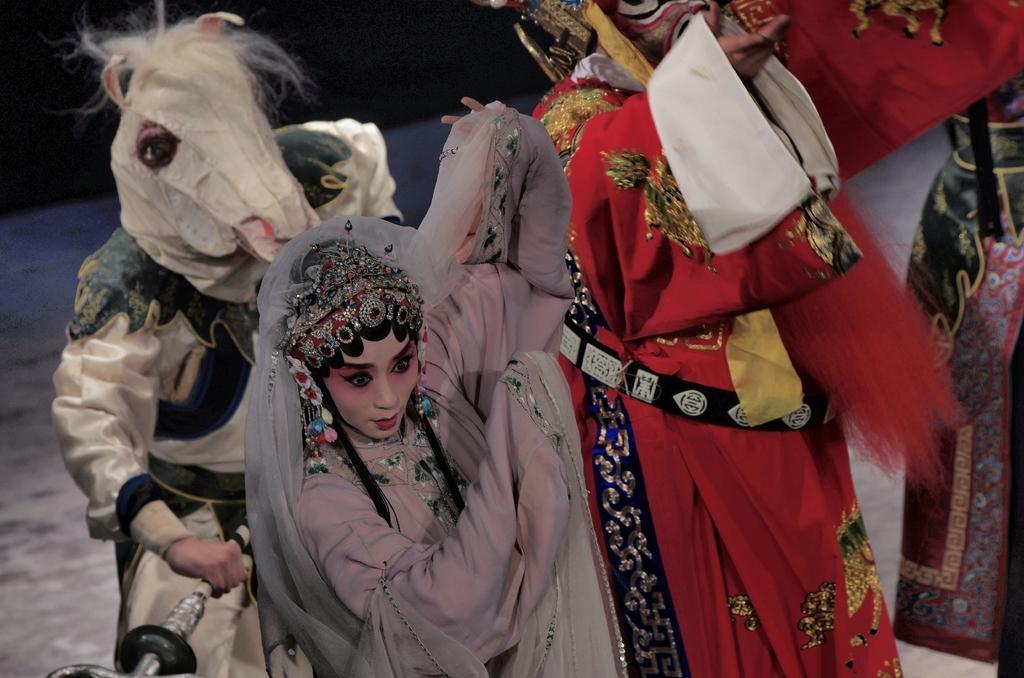Could you give a brief overview of what you see in this image? In the image I can see sculptures of persons and some other things. These sculptures has costumes on them. 